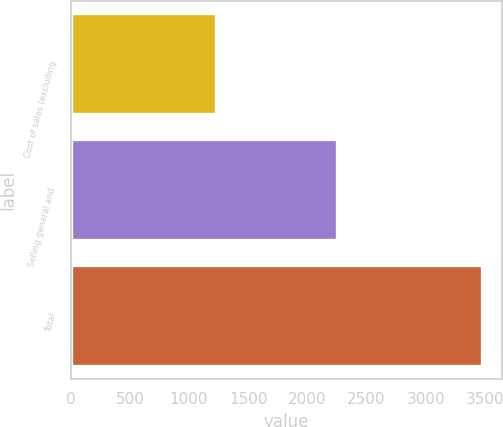<chart> <loc_0><loc_0><loc_500><loc_500><bar_chart><fcel>Cost of sales (excluding<fcel>Selling general and<fcel>Total<nl><fcel>1228<fcel>2247<fcel>3475<nl></chart> 